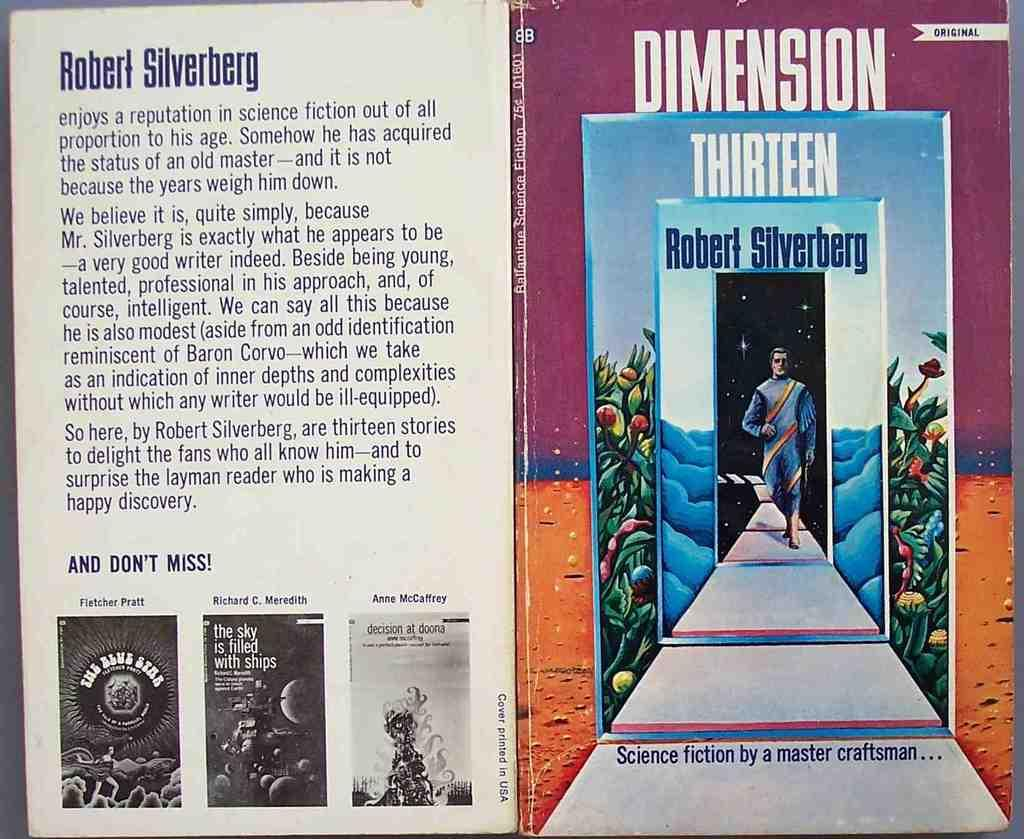Provide a one-sentence caption for the provided image. A book cover called Dimension Thirteen by Robert Silverberg. 